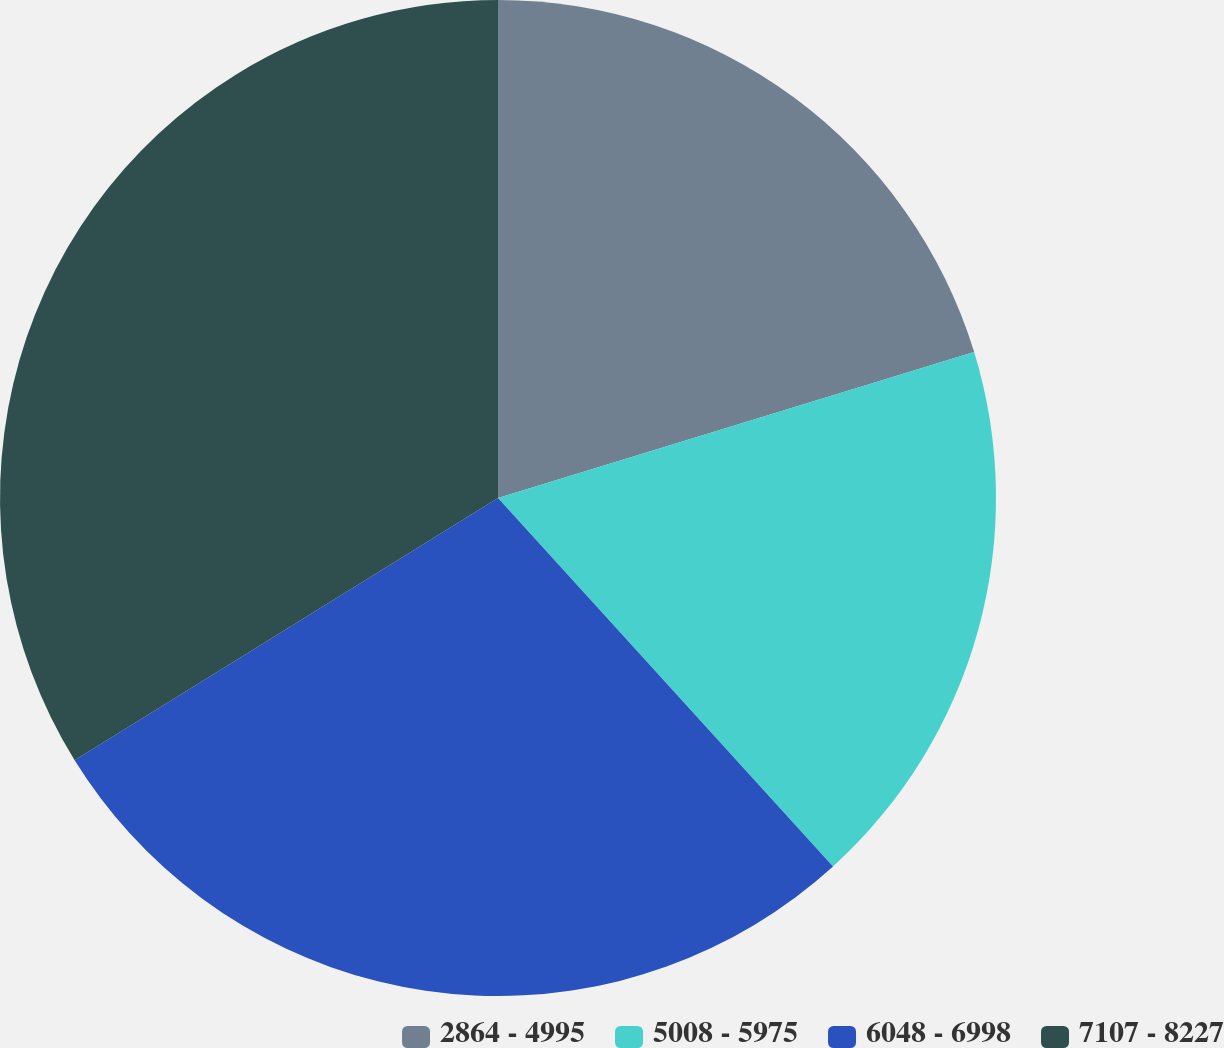Convert chart. <chart><loc_0><loc_0><loc_500><loc_500><pie_chart><fcel>2864 - 4995<fcel>5008 - 5975<fcel>6048 - 6998<fcel>7107 - 8227<nl><fcel>20.27%<fcel>17.99%<fcel>27.92%<fcel>33.83%<nl></chart> 